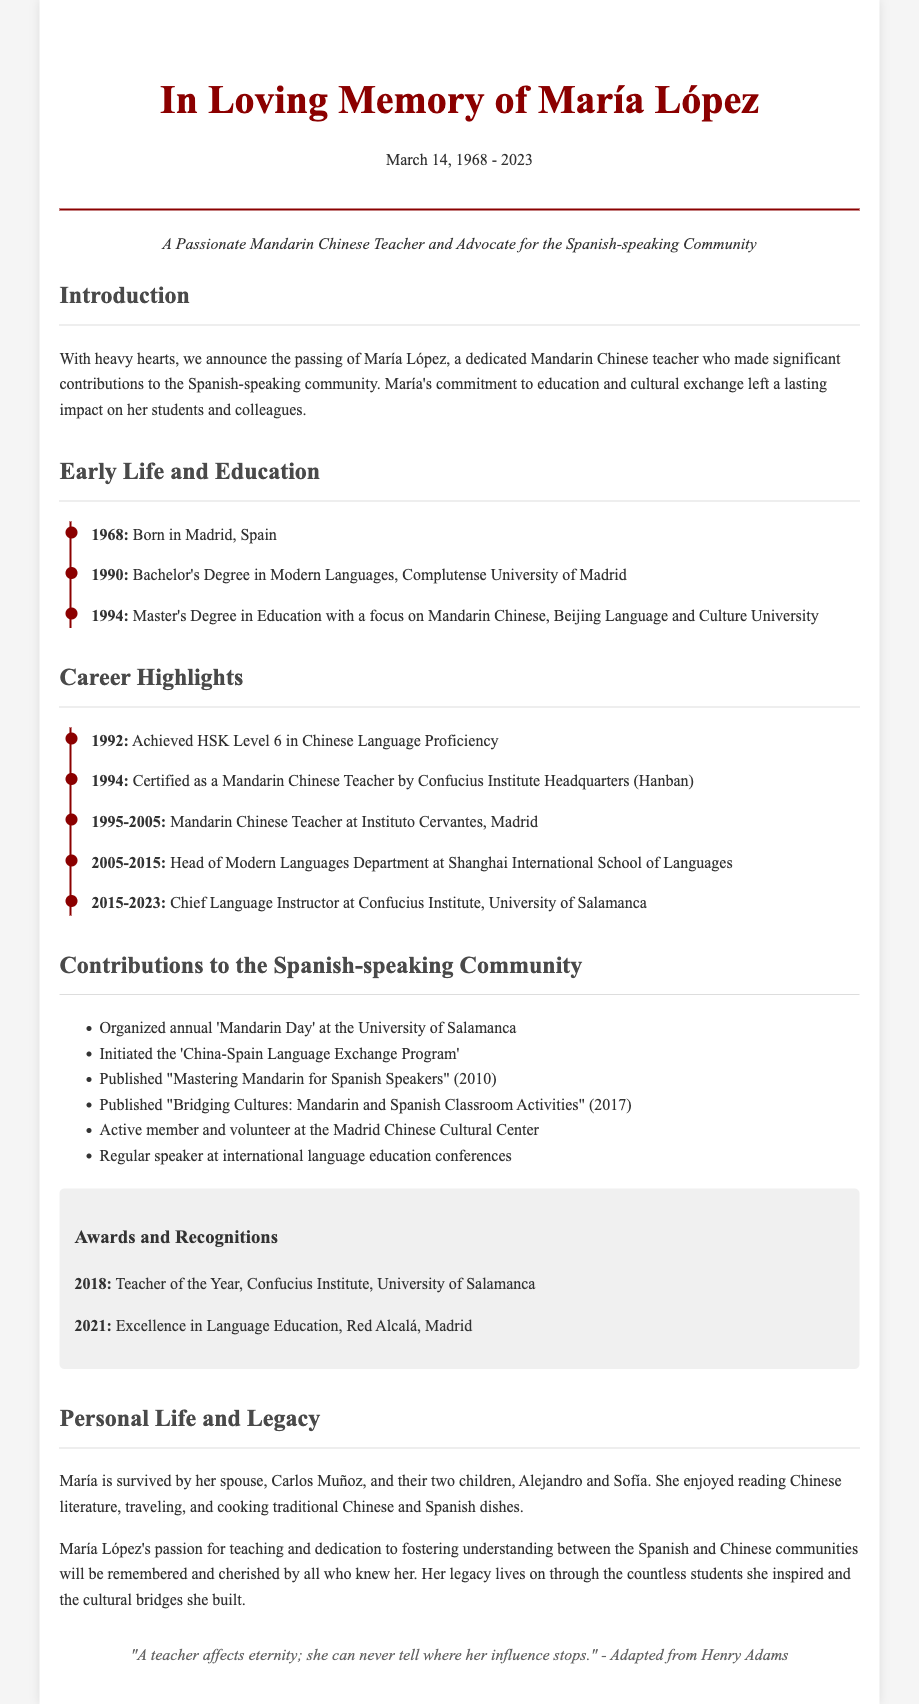What date was María López born? The document states that María López was born in 1968.
Answer: 1968 What degree did María López obtain in 1990? According to the document, María López earned a Bachelor's Degree in Modern Languages in 1990.
Answer: Bachelor's Degree in Modern Languages What award did María receive in 2018? The document mentions that María was awarded Teacher of the Year in 2018 from the Confucius Institute, University of Salamanca.
Answer: Teacher of the Year Where did María work from 1995 to 2005? The obituary states that María worked as a Mandarin Chinese Teacher at Instituto Cervantes, Madrid during this time.
Answer: Instituto Cervantes, Madrid What was one of María's contributions to the Spanish-speaking community? The document highlights that she organized the annual 'Mandarin Day' at the University of Salamanca as a significant contribution.
Answer: 'Mandarin Day' How many children did María López have? The document mentions that María is survived by two children, Alejandro and Sofía.
Answer: Two children What was the years range of María's career at Shanghai International School of Languages? The document specifies that she worked there from 2005 to 2015.
Answer: 2005-2015 What did María López publish in 2017? The document notes that María published "Bridging Cultures: Mandarin and Spanish Classroom Activities" in 2017.
Answer: "Bridging Cultures: Mandarin and Spanish Classroom Activities" What is a key focus of María's pedagogy? The obituary emphasizes her dedication to cultural exchange between the Spanish and Chinese communities.
Answer: Cultural exchange 